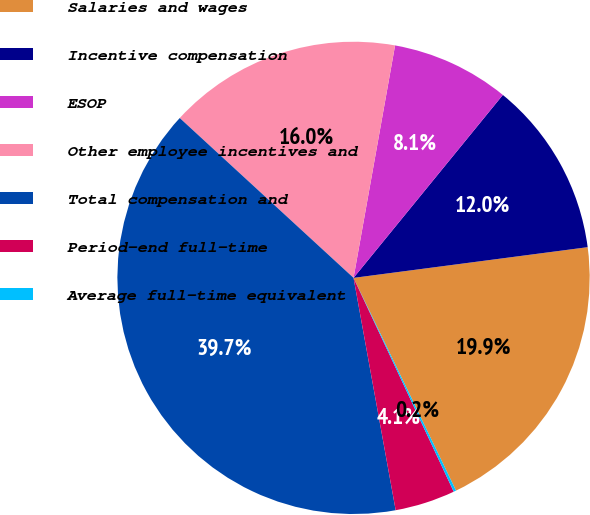<chart> <loc_0><loc_0><loc_500><loc_500><pie_chart><fcel>Salaries and wages<fcel>Incentive compensation<fcel>ESOP<fcel>Other employee incentives and<fcel>Total compensation and<fcel>Period-end full-time<fcel>Average full-time equivalent<nl><fcel>19.93%<fcel>12.03%<fcel>8.08%<fcel>15.98%<fcel>39.69%<fcel>4.12%<fcel>0.17%<nl></chart> 